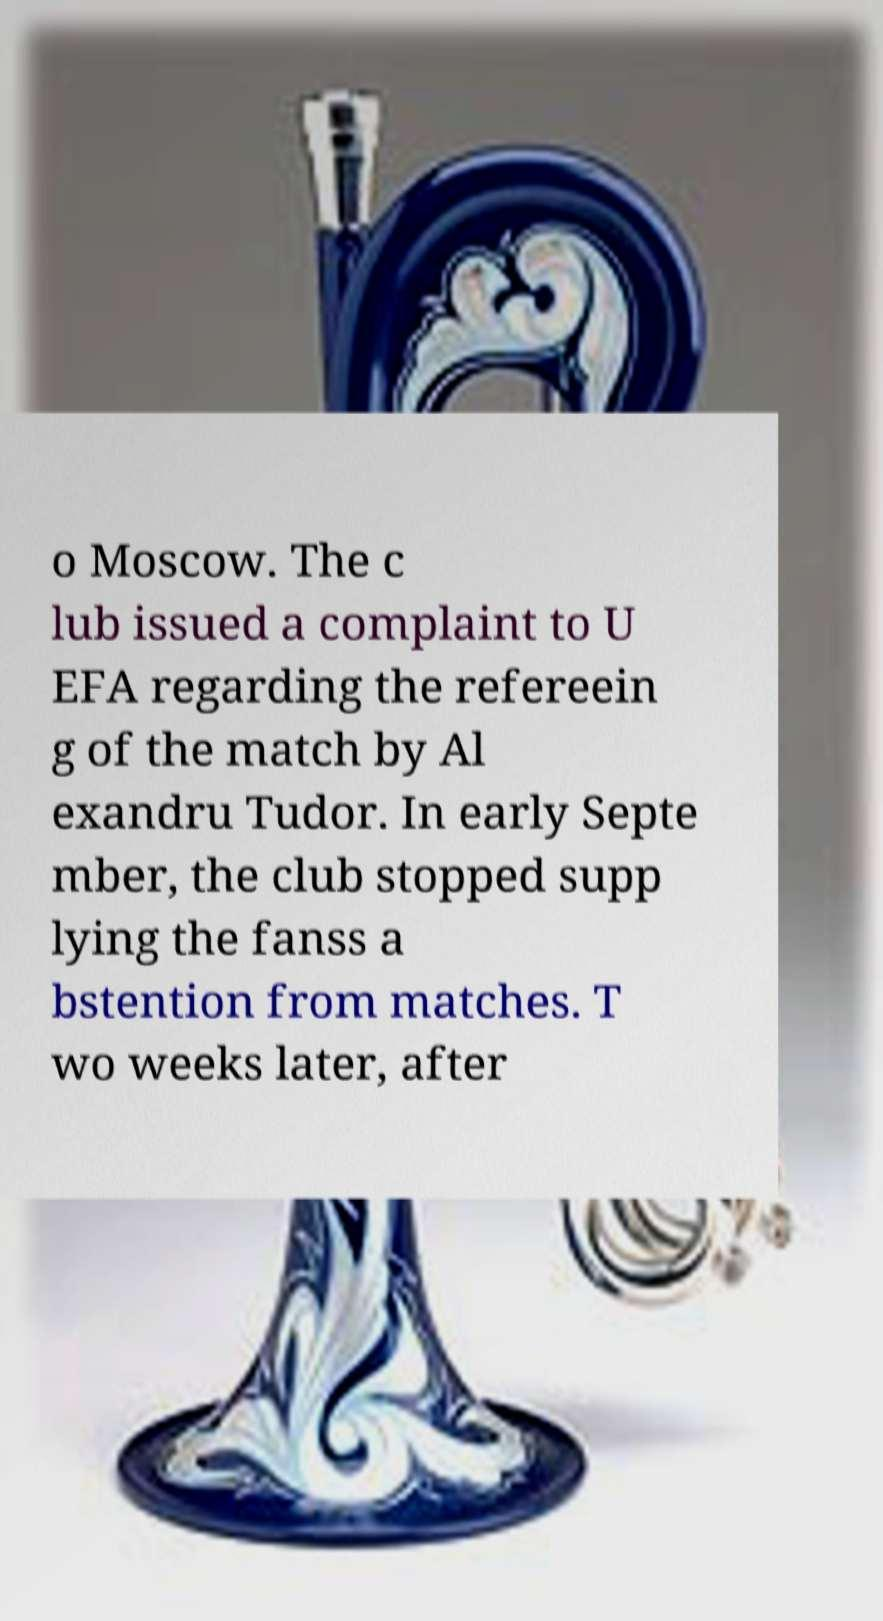Please read and relay the text visible in this image. What does it say? o Moscow. The c lub issued a complaint to U EFA regarding the refereein g of the match by Al exandru Tudor. In early Septe mber, the club stopped supp lying the fanss a bstention from matches. T wo weeks later, after 